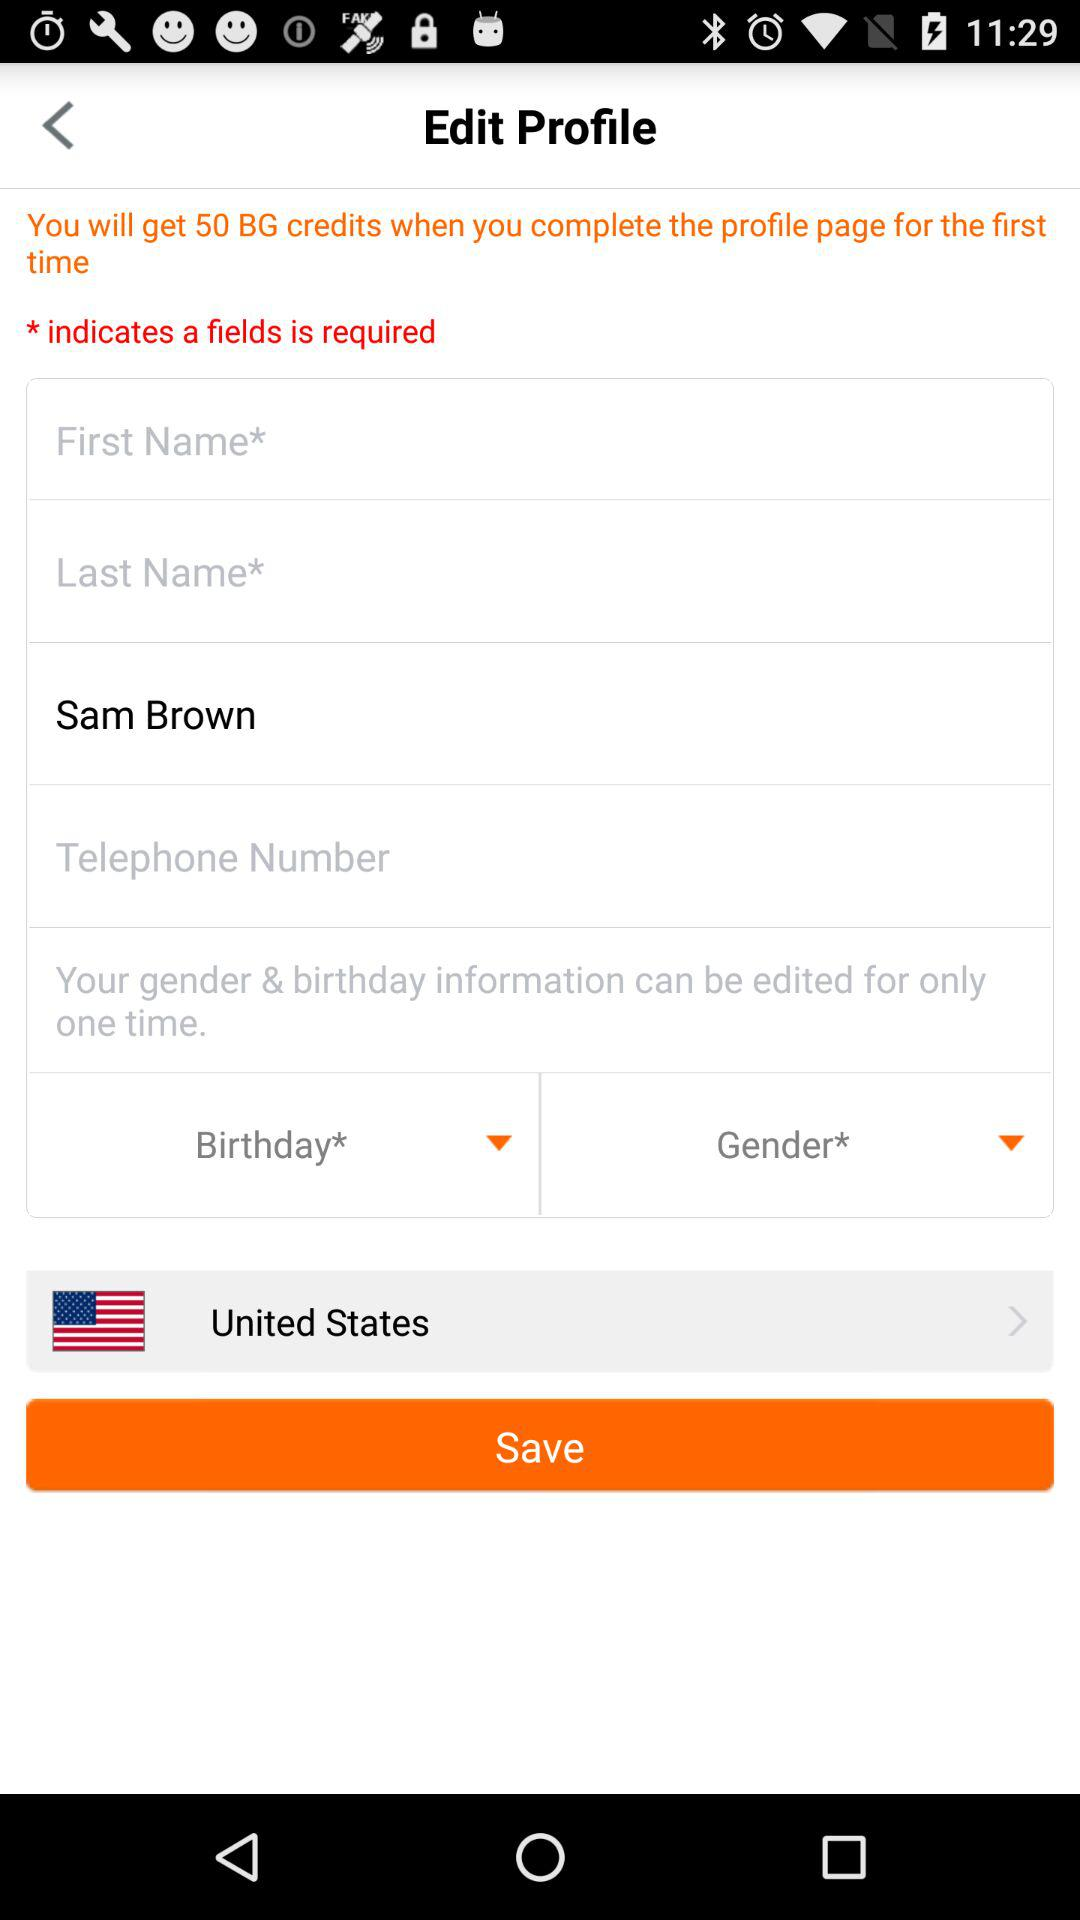What country does Sam belong to? Sam belongs to the United States. 